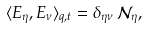<formula> <loc_0><loc_0><loc_500><loc_500>\langle E _ { \eta } , E _ { \nu } \rangle _ { q , t } = \delta _ { \eta \nu } \, \mathcal { N } _ { \eta } ,</formula> 